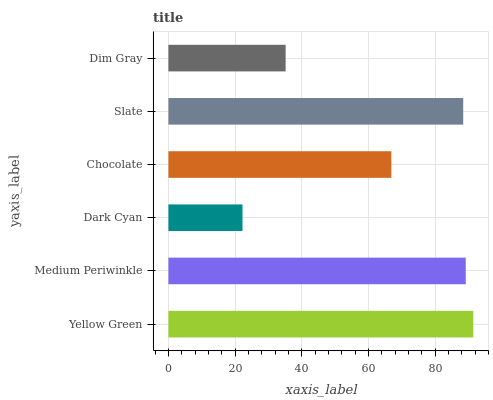Is Dark Cyan the minimum?
Answer yes or no. Yes. Is Yellow Green the maximum?
Answer yes or no. Yes. Is Medium Periwinkle the minimum?
Answer yes or no. No. Is Medium Periwinkle the maximum?
Answer yes or no. No. Is Yellow Green greater than Medium Periwinkle?
Answer yes or no. Yes. Is Medium Periwinkle less than Yellow Green?
Answer yes or no. Yes. Is Medium Periwinkle greater than Yellow Green?
Answer yes or no. No. Is Yellow Green less than Medium Periwinkle?
Answer yes or no. No. Is Slate the high median?
Answer yes or no. Yes. Is Chocolate the low median?
Answer yes or no. Yes. Is Dim Gray the high median?
Answer yes or no. No. Is Dim Gray the low median?
Answer yes or no. No. 